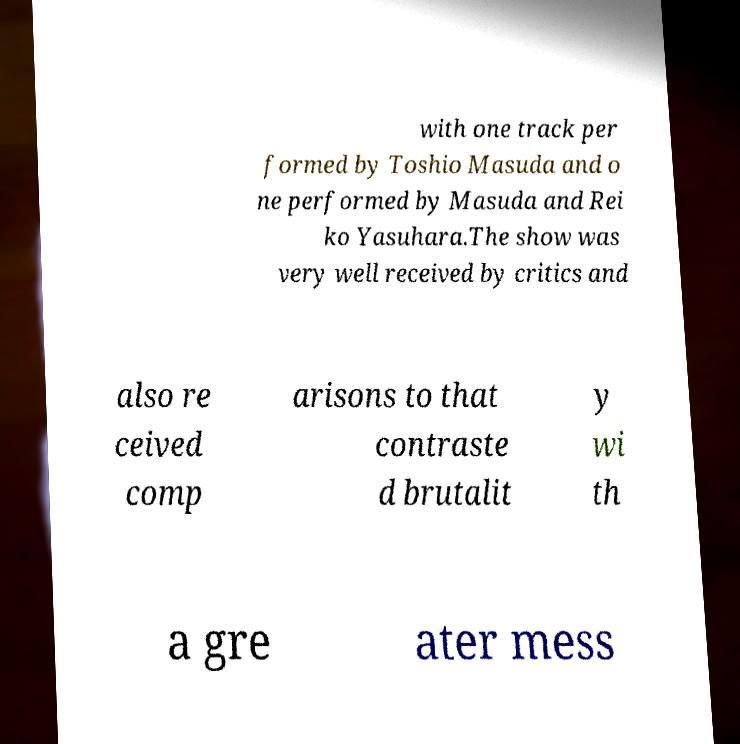There's text embedded in this image that I need extracted. Can you transcribe it verbatim? with one track per formed by Toshio Masuda and o ne performed by Masuda and Rei ko Yasuhara.The show was very well received by critics and also re ceived comp arisons to that contraste d brutalit y wi th a gre ater mess 